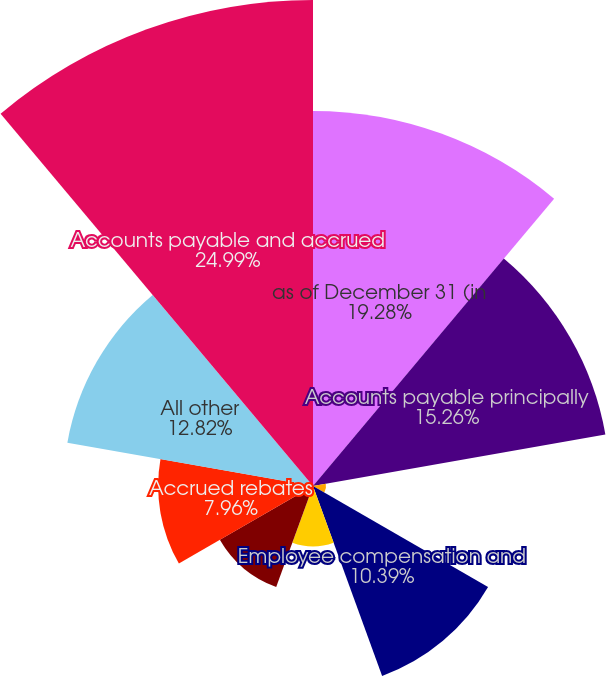<chart> <loc_0><loc_0><loc_500><loc_500><pie_chart><fcel>as of December 31 (in<fcel>Accounts payable principally<fcel>Common stock dividends payable<fcel>Employee compensation and<fcel>Property payroll and certain<fcel>Business optimization reserves<fcel>Accrued rebates<fcel>All other<fcel>Accounts payable and accrued<nl><fcel>19.28%<fcel>15.26%<fcel>0.67%<fcel>10.39%<fcel>3.1%<fcel>5.53%<fcel>7.96%<fcel>12.82%<fcel>24.98%<nl></chart> 